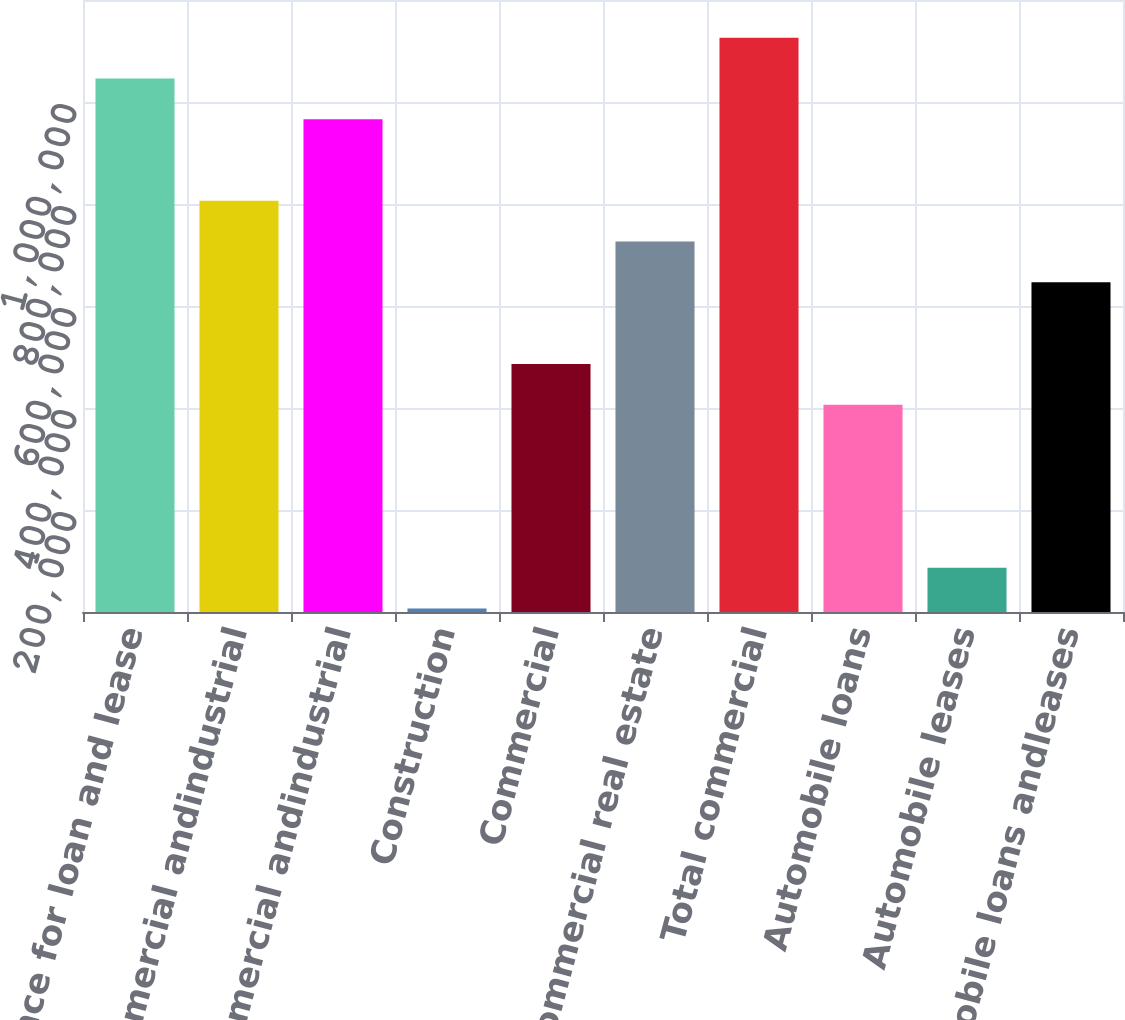Convert chart. <chart><loc_0><loc_0><loc_500><loc_500><bar_chart><fcel>Allowance for loan and lease<fcel>Other commercial andindustrial<fcel>Commercial andindustrial<fcel>Construction<fcel>Commercial<fcel>Commercial real estate<fcel>Total commercial<fcel>Automobile loans<fcel>Automobile leases<fcel>Automobile loans andleases<nl><fcel>1.04624e+06<fcel>806330<fcel>966270<fcel>6631<fcel>486450<fcel>726360<fcel>1.12621e+06<fcel>406480<fcel>86600.9<fcel>646390<nl></chart> 